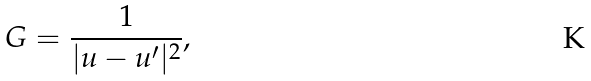<formula> <loc_0><loc_0><loc_500><loc_500>G = \frac { 1 } { | u - u ^ { \prime } | ^ { 2 } } ,</formula> 